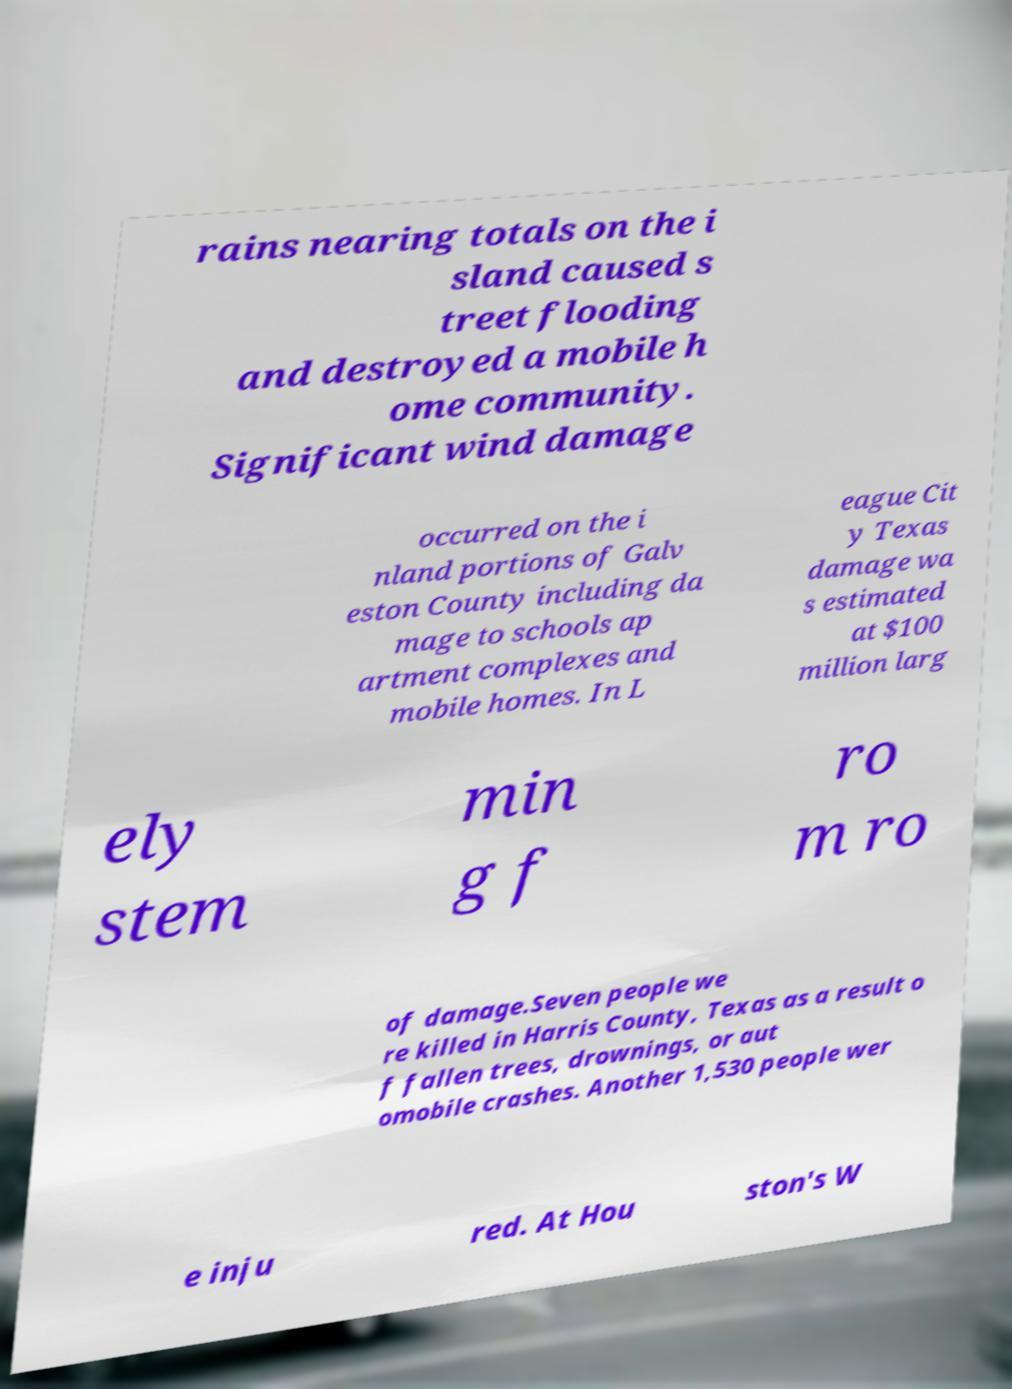I need the written content from this picture converted into text. Can you do that? rains nearing totals on the i sland caused s treet flooding and destroyed a mobile h ome community. Significant wind damage occurred on the i nland portions of Galv eston County including da mage to schools ap artment complexes and mobile homes. In L eague Cit y Texas damage wa s estimated at $100 million larg ely stem min g f ro m ro of damage.Seven people we re killed in Harris County, Texas as a result o f fallen trees, drownings, or aut omobile crashes. Another 1,530 people wer e inju red. At Hou ston's W 